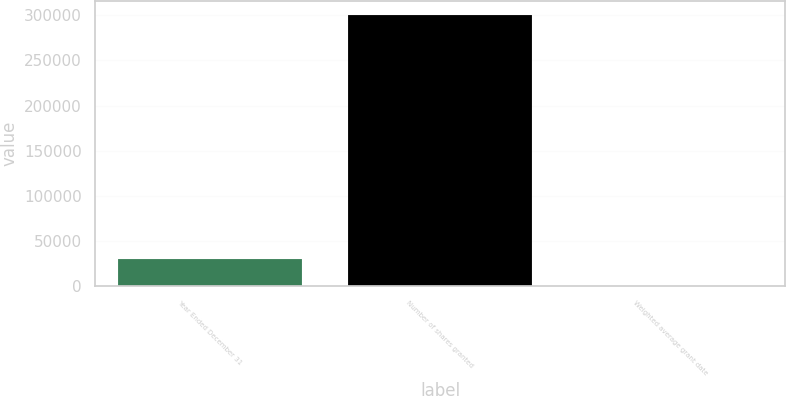<chart> <loc_0><loc_0><loc_500><loc_500><bar_chart><fcel>Year Ended December 31<fcel>Number of shares granted<fcel>Weighted average grant date<nl><fcel>30131.3<fcel>300784<fcel>58.83<nl></chart> 